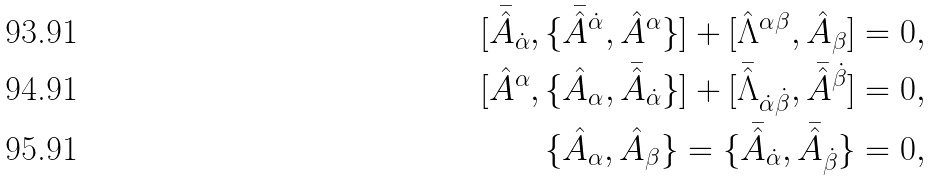Convert formula to latex. <formula><loc_0><loc_0><loc_500><loc_500>[ \bar { \hat { A } } _ { \dot { \alpha } } , \{ \bar { \hat { A } } ^ { \dot { \alpha } } , \hat { A } ^ { \alpha } \} ] + [ \hat { \Lambda } ^ { \alpha \beta } , \hat { A } _ { \beta } ] & = 0 , \\ [ \hat { A } ^ { \alpha } , \{ \hat { A } _ { \alpha } , \bar { \hat { A } } _ { \dot { \alpha } } \} ] + [ \bar { \hat { \Lambda } } _ { \dot { \alpha } \dot { \beta } } , \bar { \hat { A } } ^ { \dot { \beta } } ] & = 0 , \\ \{ \hat { A } _ { \alpha } , \hat { A } _ { \beta } \} = \{ \bar { \hat { A } } _ { \dot { \alpha } } , \bar { \hat { A } } _ { \dot { \beta } } \} & = 0 ,</formula> 